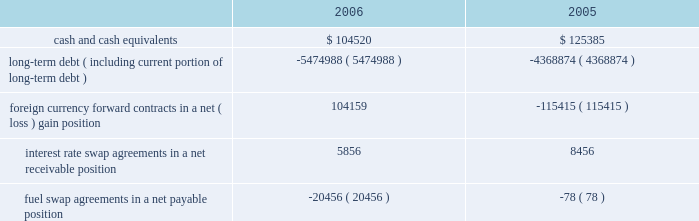Note 9 .
Retirement plan we maintain a defined contribution pension plan covering full-time shoreside employees who have completed the minimum period of continuous service .
Annual contributions to the plan are based on fixed percentages of participants 2019 salaries and years of service , not to exceed certain maximums .
Pension cost was $ 13.9 million , $ 12.8 million and $ 12.2 million for the years ended december 31 , 2006 , 2005 and 2004 , respectively .
Note 10 .
Income taxes we and the majority of our subsidiaries are currently exempt from united states corporate tax on income from the international opera- tion of ships pursuant to section 883 of the internal revenue code .
Income tax expense related to our remaining subsidiaries was not significant for the years ended december 31 , 2006 , 2005 and 2004 .
Final regulations under section 883 were published on august 26 , 2003 , and were effective for the year ended december 31 , 2005 .
These regulations confirmed that we qualify for the exemption provid- ed by section 883 , but also narrowed the scope of activities which are considered by the internal revenue service to be incidental to the international operation of ships .
The activities listed in the regula- tions as not being incidental to the international operation of ships include income from the sale of air and other transportation such as transfers , shore excursions and pre and post cruise tours .
To the extent the income from such activities is earned from sources within the united states , such income will be subject to united states taxa- tion .
The application of these new regulations reduced our net income for the years ended december 31 , 2006 and december 31 , 2005 by approximately $ 6.3 million and $ 14.0 million , respectively .
Note 11 .
Financial instruments the estimated fair values of our financial instruments are as follows ( in thousands ) : .
Long-term debt ( including current portion of long-term debt ) ( 5474988 ) ( 4368874 ) foreign currency forward contracts in a net ( loss ) gain position 104159 ( 115415 ) interest rate swap agreements in a net receivable position 5856 8456 fuel swap agreements in a net payable position ( 20456 ) ( 78 ) the reported fair values are based on a variety of factors and assumptions .
Accordingly , the fair values may not represent actual values of the financial instruments that could have been realized as of december 31 , 2006 or 2005 , or that will be realized in the future and do not include expenses that could be incurred in an actual sale or settlement .
Our financial instruments are not held for trading or speculative purposes .
Our exposure under foreign currency contracts , interest rate and fuel swap agreements is limited to the cost of replacing the contracts in the event of non-performance by the counterparties to the contracts , all of which are currently our lending banks .
To minimize this risk , we select counterparties with credit risks acceptable to us and we limit our exposure to an individual counterparty .
Furthermore , all foreign currency forward contracts are denominated in primary currencies .
Cash and cash equivalents the carrying amounts of cash and cash equivalents approximate their fair values due to the short maturity of these instruments .
Long-term debt the fair values of our senior notes and senior debentures were esti- mated by obtaining quoted market prices .
The fair values of all other debt were estimated using discounted cash flow analyses based on market rates available to us for similar debt with the same remaining maturities .
Foreign currency contracts the fair values of our foreign currency forward contracts were esti- mated using current market prices for similar instruments .
Our expo- sure to market risk for fluctuations in foreign currency exchange rates relates to six ship construction contracts and forecasted transactions .
We use foreign currency forward contracts to mitigate the impact of fluctuations in foreign currency exchange rates .
As of december 31 , 2006 , we had foreign currency forward contracts in a notional amount of $ 3.8 billion maturing through 2009 .
As of december 31 , 2006 , the fair value of our foreign currency forward contracts related to the six ship construction contracts , which are designated as fair value hedges , was a net unrealized gain of approximately $ 106.3 mil- lion .
At december 31 , 2005 , the fair value of our foreign currency for- ward contracts related to three ship construction contracts , designated as fair value hedges , was a net unrealized loss of approx- imately $ 103.4 million .
The fair value of our foreign currency forward contracts related to the other ship construction contract at december 31 , 2005 , which was designated as a cash flow hedge , was an unre- alized loss , of approximately $ 7.8 million .
At december 31 , 2006 , approximately 11% ( 11 % ) of the aggregate cost of the ships was exposed to fluctuations in the euro exchange rate .
R o y a l c a r i b b e a n c r u i s e s l t d .
3 5 notes to the consolidated financial statements ( continued ) 51392_financials-v9.qxp 6/7/07 3:40 pm page 35 .
What was the percentage increase in the annual pension costs from 2005 to 2006? 
Computations: ((13.9 - 12.2) / 12.2)
Answer: 0.13934. 